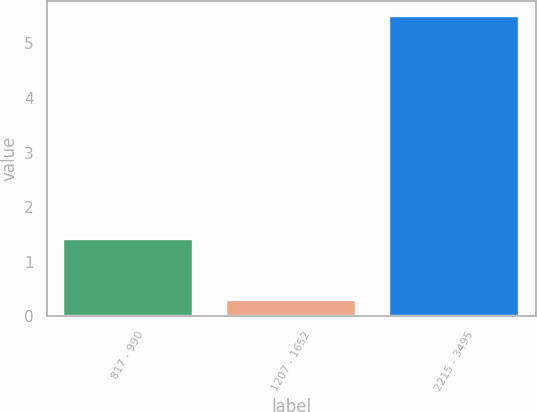Convert chart. <chart><loc_0><loc_0><loc_500><loc_500><bar_chart><fcel>817 - 990<fcel>1207 - 1652<fcel>2215 - 3495<nl><fcel>1.42<fcel>0.3<fcel>5.5<nl></chart> 